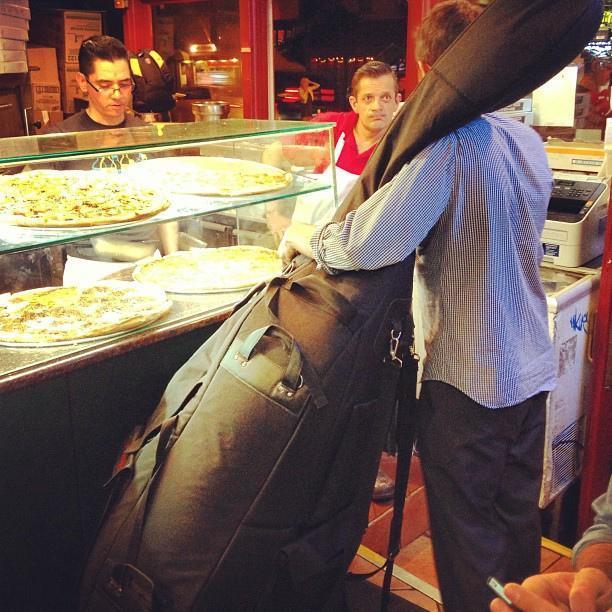How many trays of food are under the heat lamp?
Give a very brief answer. 4. How many people can you see?
Give a very brief answer. 3. How many pizzas can be seen?
Give a very brief answer. 4. How many empty chairs are pictured?
Give a very brief answer. 0. 